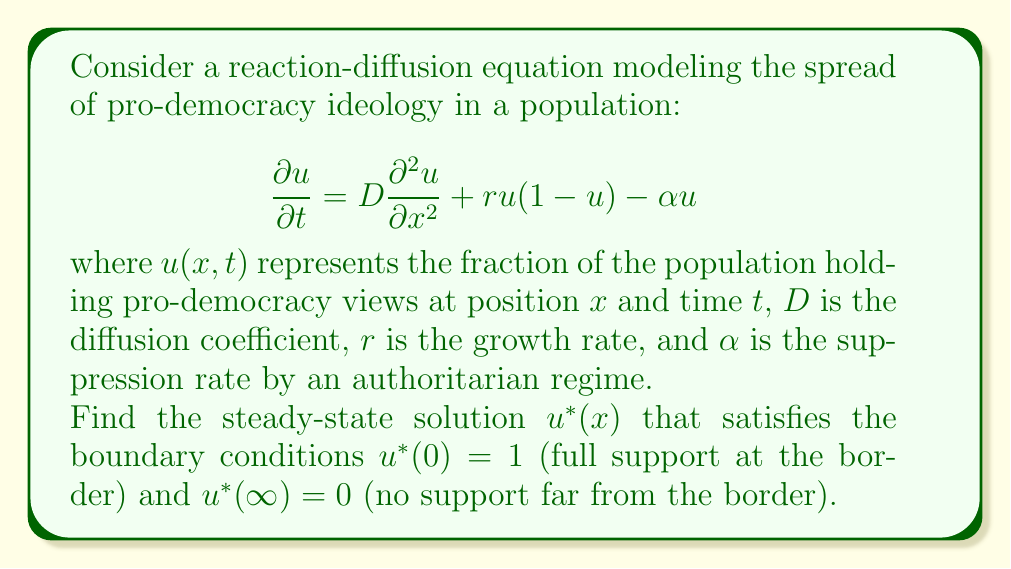Can you solve this math problem? To solve this problem, we follow these steps:

1) For the steady-state solution, $\frac{\partial u}{\partial t} = 0$. So, our equation becomes:

   $$D\frac{d^2 u^*}{dx^2} + ru^*(1-u^*) - \alpha u^* = 0$$

2) Let's introduce a new variable $z = \sqrt{\frac{r}{D}}x$. This transforms our equation to:

   $$\frac{d^2 u^*}{dz^2} + u^*(1-u^*) - \frac{\alpha}{r}u^* = 0$$

3) We're looking for a solution of the form $u^*(z) = \frac{1}{(1+ce^{kz})^2}$, where $c$ and $k$ are constants to be determined.

4) Substituting this into our equation and simplifying, we get:

   $$k^2 = 1 - \frac{\alpha}{r}$$

5) To satisfy the boundary condition $u^*(\infty) = 0$, we need $k > 0$. So:

   $$k = \sqrt{1 - \frac{\alpha}{r}}$$

6) The condition $u^*(0) = 1$ implies $c = 1$.

7) Transforming back to the original variable $x$, our solution is:

   $$u^*(x) = \frac{1}{(1+e^{\sqrt{\frac{r}{D}(1-\frac{\alpha}{r})}x})^2}$$

This solution represents a "traveling wave" of pro-democracy ideology spreading from the border into the country, with its rate of spread determined by the balance between diffusion, growth, and suppression.
Answer: $$u^*(x) = \frac{1}{(1+e^{\sqrt{\frac{r}{D}(1-\frac{\alpha}{r})}x})^2}$$ 